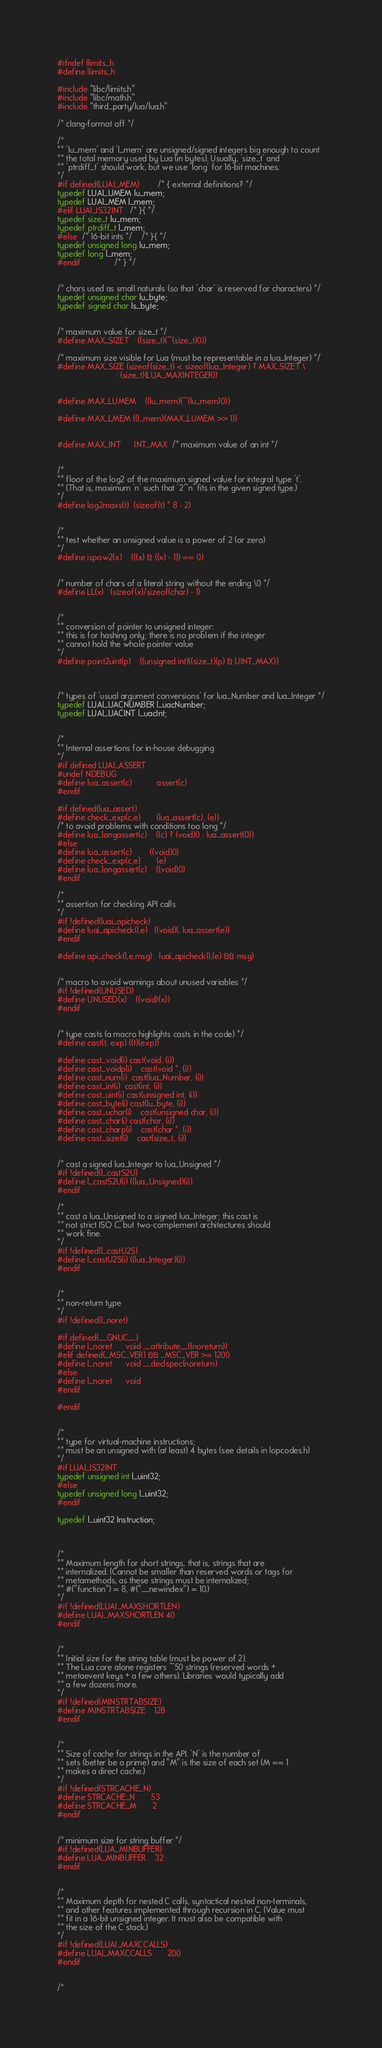Convert code to text. <code><loc_0><loc_0><loc_500><loc_500><_C_>#ifndef llimits_h
#define llimits_h

#include "libc/limits.h"
#include "libc/math.h"
#include "third_party/lua/lua.h"

/* clang-format off */

/*
** 'lu_mem' and 'l_mem' are unsigned/signed integers big enough to count
** the total memory used by Lua (in bytes). Usually, 'size_t' and
** 'ptrdiff_t' should work, but we use 'long' for 16-bit machines.
*/
#if defined(LUAI_MEM)		/* { external definitions? */
typedef LUAI_UMEM lu_mem;
typedef LUAI_MEM l_mem;
#elif LUAI_IS32INT	/* }{ */
typedef size_t lu_mem;
typedef ptrdiff_t l_mem;
#else  /* 16-bit ints */	/* }{ */
typedef unsigned long lu_mem;
typedef long l_mem;
#endif				/* } */


/* chars used as small naturals (so that 'char' is reserved for characters) */
typedef unsigned char lu_byte;
typedef signed char ls_byte;


/* maximum value for size_t */
#define MAX_SIZET	((size_t)(~(size_t)0))

/* maximum size visible for Lua (must be representable in a lua_Integer) */
#define MAX_SIZE	(sizeof(size_t) < sizeof(lua_Integer) ? MAX_SIZET \
                          : (size_t)(LUA_MAXINTEGER))


#define MAX_LUMEM	((lu_mem)(~(lu_mem)0))

#define MAX_LMEM	((l_mem)(MAX_LUMEM >> 1))


#define MAX_INT		INT_MAX  /* maximum value of an int */


/*
** floor of the log2 of the maximum signed value for integral type 't'.
** (That is, maximum 'n' such that '2^n' fits in the given signed type.)
*/
#define log2maxs(t)	(sizeof(t) * 8 - 2)


/*
** test whether an unsigned value is a power of 2 (or zero)
*/
#define ispow2(x)	(((x) & ((x) - 1)) == 0)


/* number of chars of a literal string without the ending \0 */
#define LL(x)   (sizeof(x)/sizeof(char) - 1)


/*
** conversion of pointer to unsigned integer:
** this is for hashing only; there is no problem if the integer
** cannot hold the whole pointer value
*/
#define point2uint(p)	((unsigned int)((size_t)(p) & UINT_MAX))



/* types of 'usual argument conversions' for lua_Number and lua_Integer */
typedef LUAI_UACNUMBER l_uacNumber;
typedef LUAI_UACINT l_uacInt;


/*
** Internal assertions for in-house debugging
*/
#if defined LUAI_ASSERT
#undef NDEBUG
#define lua_assert(c)           assert(c)
#endif

#if defined(lua_assert)
#define check_exp(c,e)		(lua_assert(c), (e))
/* to avoid problems with conditions too long */
#define lua_longassert(c)	((c) ? (void)0 : lua_assert(0))
#else
#define lua_assert(c)		((void)0)
#define check_exp(c,e)		(e)
#define lua_longassert(c)	((void)0)
#endif

/*
** assertion for checking API calls
*/
#if !defined(luai_apicheck)
#define luai_apicheck(l,e)	((void)l, lua_assert(e))
#endif

#define api_check(l,e,msg)	luai_apicheck(l,(e) && msg)


/* macro to avoid warnings about unused variables */
#if !defined(UNUSED)
#define UNUSED(x)	((void)(x))
#endif


/* type casts (a macro highlights casts in the code) */
#define cast(t, exp)	((t)(exp))

#define cast_void(i)	cast(void, (i))
#define cast_voidp(i)	cast(void *, (i))
#define cast_num(i)	cast(lua_Number, (i))
#define cast_int(i)	cast(int, (i))
#define cast_uint(i)	cast(unsigned int, (i))
#define cast_byte(i)	cast(lu_byte, (i))
#define cast_uchar(i)	cast(unsigned char, (i))
#define cast_char(i)	cast(char, (i))
#define cast_charp(i)	cast(char *, (i))
#define cast_sizet(i)	cast(size_t, (i))


/* cast a signed lua_Integer to lua_Unsigned */
#if !defined(l_castS2U)
#define l_castS2U(i)	((lua_Unsigned)(i))
#endif

/*
** cast a lua_Unsigned to a signed lua_Integer; this cast is
** not strict ISO C, but two-complement architectures should
** work fine.
*/
#if !defined(l_castU2S)
#define l_castU2S(i)	((lua_Integer)(i))
#endif


/*
** non-return type
*/
#if !defined(l_noret)

#if defined(__GNUC__)
#define l_noret		void __attribute__((noreturn))
#elif defined(_MSC_VER) && _MSC_VER >= 1200
#define l_noret		void __declspec(noreturn)
#else
#define l_noret		void
#endif

#endif


/*
** type for virtual-machine instructions;
** must be an unsigned with (at least) 4 bytes (see details in lopcodes.h)
*/
#if LUAI_IS32INT
typedef unsigned int l_uint32;
#else
typedef unsigned long l_uint32;
#endif

typedef l_uint32 Instruction;



/*
** Maximum length for short strings, that is, strings that are
** internalized. (Cannot be smaller than reserved words or tags for
** metamethods, as these strings must be internalized;
** #("function") = 8, #("__newindex") = 10.)
*/
#if !defined(LUAI_MAXSHORTLEN)
#define LUAI_MAXSHORTLEN	40
#endif


/*
** Initial size for the string table (must be power of 2).
** The Lua core alone registers ~50 strings (reserved words +
** metaevent keys + a few others). Libraries would typically add
** a few dozens more.
*/
#if !defined(MINSTRTABSIZE)
#define MINSTRTABSIZE	128
#endif


/*
** Size of cache for strings in the API. 'N' is the number of
** sets (better be a prime) and "M" is the size of each set (M == 1
** makes a direct cache.)
*/
#if !defined(STRCACHE_N)
#define STRCACHE_N		53
#define STRCACHE_M		2
#endif


/* minimum size for string buffer */
#if !defined(LUA_MINBUFFER)
#define LUA_MINBUFFER	32
#endif


/*
** Maximum depth for nested C calls, syntactical nested non-terminals,
** and other features implemented through recursion in C. (Value must
** fit in a 16-bit unsigned integer. It must also be compatible with
** the size of the C stack.)
*/
#if !defined(LUAI_MAXCCALLS)
#define LUAI_MAXCCALLS		200
#endif


/*</code> 